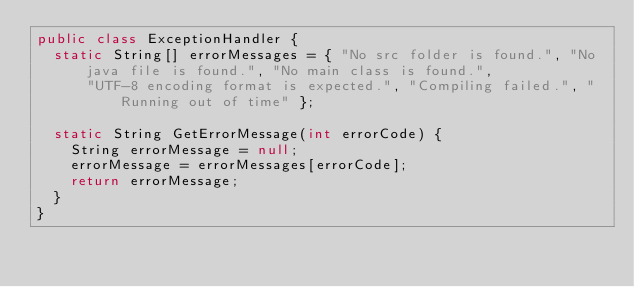<code> <loc_0><loc_0><loc_500><loc_500><_Java_>public class ExceptionHandler {
	static String[] errorMessages = { "No src folder is found.", "No java file is found.", "No main class is found.",
			"UTF-8 encoding format is expected.", "Compiling failed.", "Running out of time" };

	static String GetErrorMessage(int errorCode) {
		String errorMessage = null;
		errorMessage = errorMessages[errorCode];
		return errorMessage;
	}
}
</code> 